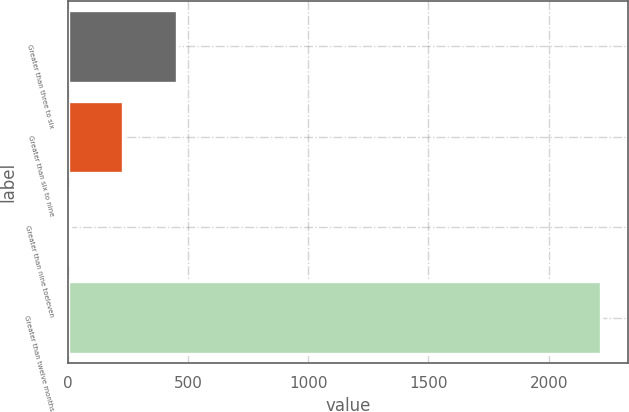<chart> <loc_0><loc_0><loc_500><loc_500><bar_chart><fcel>Greater than three to six<fcel>Greater than six to nine<fcel>Greater than nine toeleven<fcel>Greater than twelve months<nl><fcel>452.4<fcel>231.7<fcel>11<fcel>2218<nl></chart> 